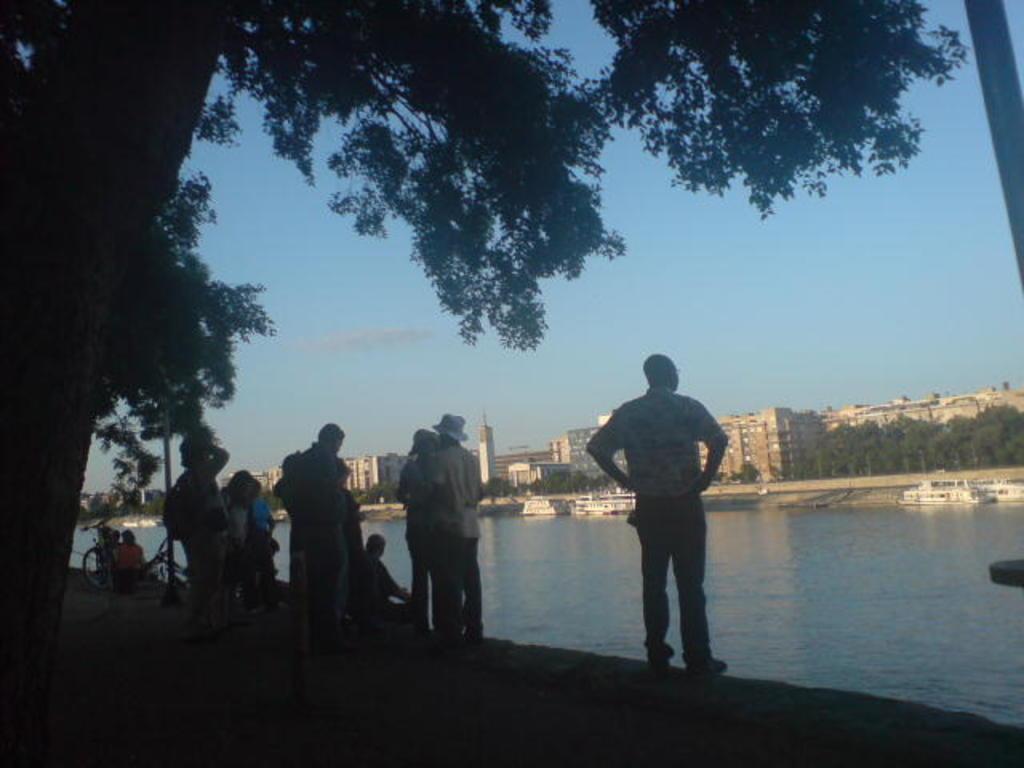Describe this image in one or two sentences. In this picture, we can see a few people, ground, poles, bicycles, trees, water, boats, and we can see a few buildings with windows, and the sky. 